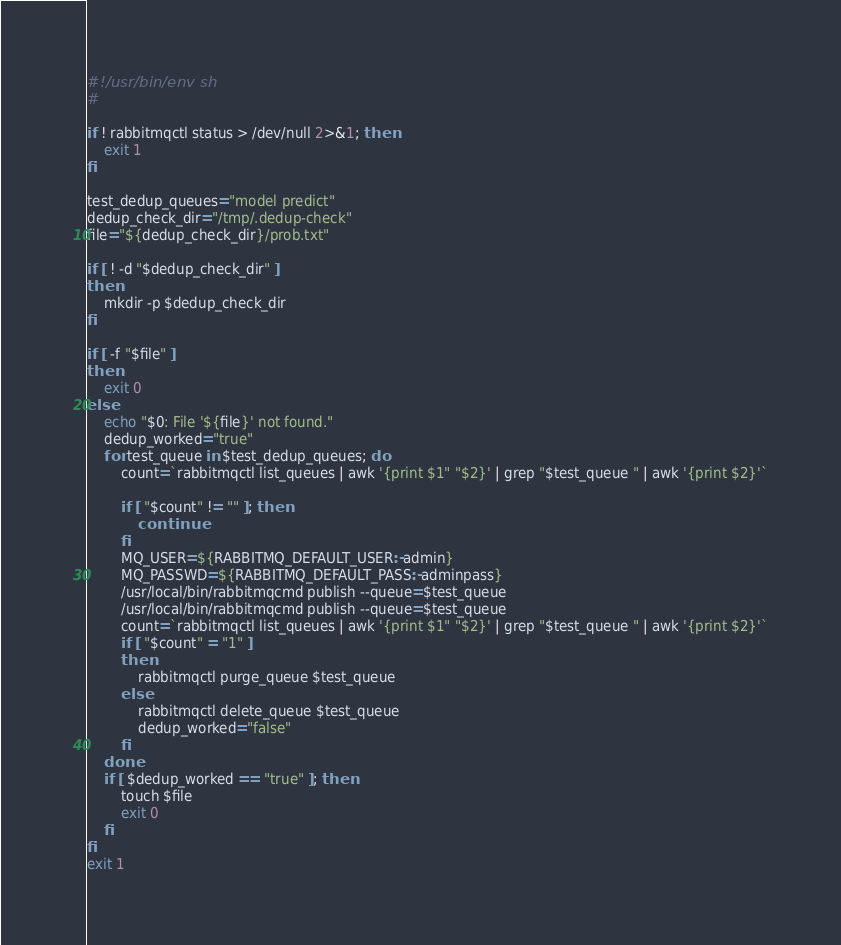Convert code to text. <code><loc_0><loc_0><loc_500><loc_500><_Bash_>#!/usr/bin/env sh
#

if ! rabbitmqctl status > /dev/null 2>&1; then
    exit 1
fi

test_dedup_queues="model predict"
dedup_check_dir="/tmp/.dedup-check"
file="${dedup_check_dir}/prob.txt"

if [ ! -d "$dedup_check_dir" ]
then
    mkdir -p $dedup_check_dir
fi

if [ -f "$file" ]
then
    exit 0
else
    echo "$0: File '${file}' not found."
    dedup_worked="true"
    for test_queue in $test_dedup_queues; do
        count=`rabbitmqctl list_queues | awk '{print $1" "$2}' | grep "$test_queue " | awk '{print $2}'`

        if [ "$count" != "" ]; then
            continue
        fi
        MQ_USER=${RABBITMQ_DEFAULT_USER:-admin}
        MQ_PASSWD=${RABBITMQ_DEFAULT_PASS:-adminpass}
        /usr/local/bin/rabbitmqcmd publish --queue=$test_queue
        /usr/local/bin/rabbitmqcmd publish --queue=$test_queue
        count=`rabbitmqctl list_queues | awk '{print $1" "$2}' | grep "$test_queue " | awk '{print $2}'`
        if [ "$count" = "1" ]
        then
            rabbitmqctl purge_queue $test_queue
        else
            rabbitmqctl delete_queue $test_queue
            dedup_worked="false"
        fi
    done
    if [ $dedup_worked == "true" ]; then
        touch $file
        exit 0
    fi
fi
exit 1
</code> 